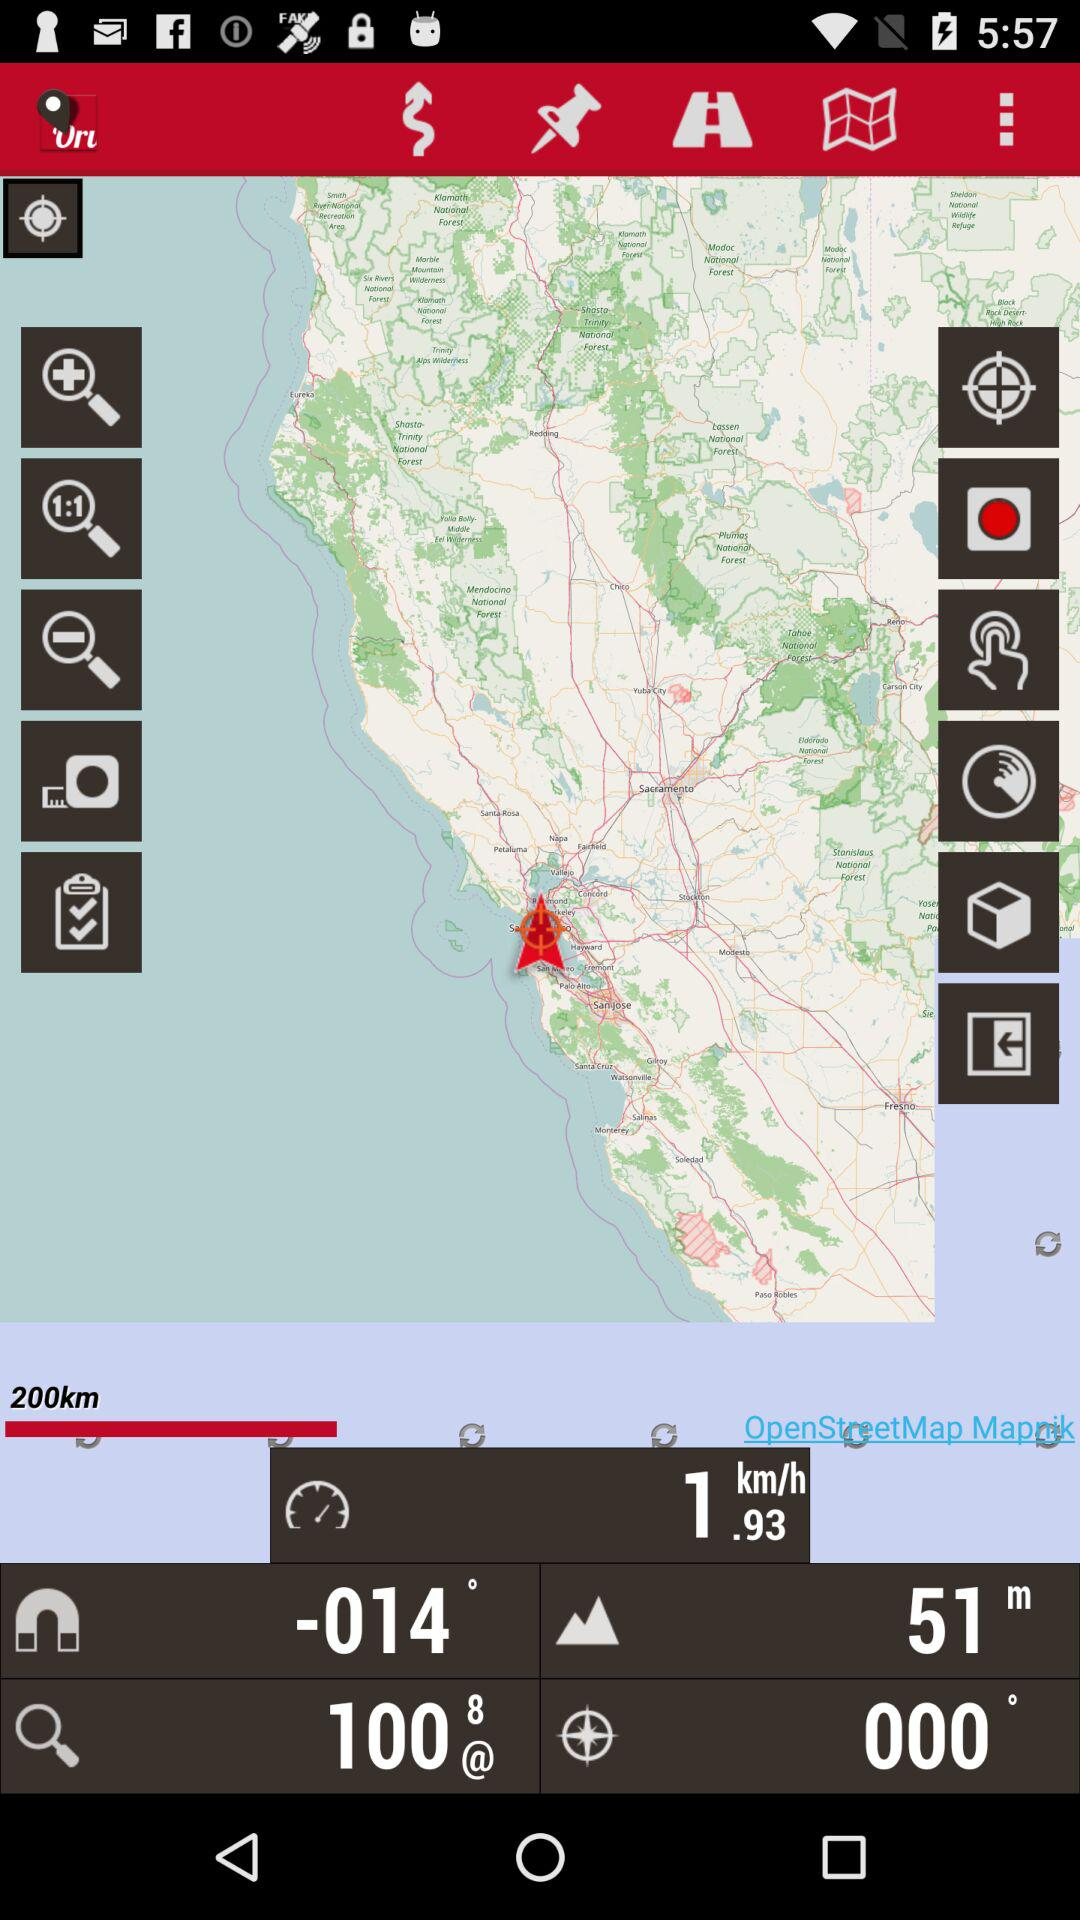What is the elevation? The elevation is 51 m. 